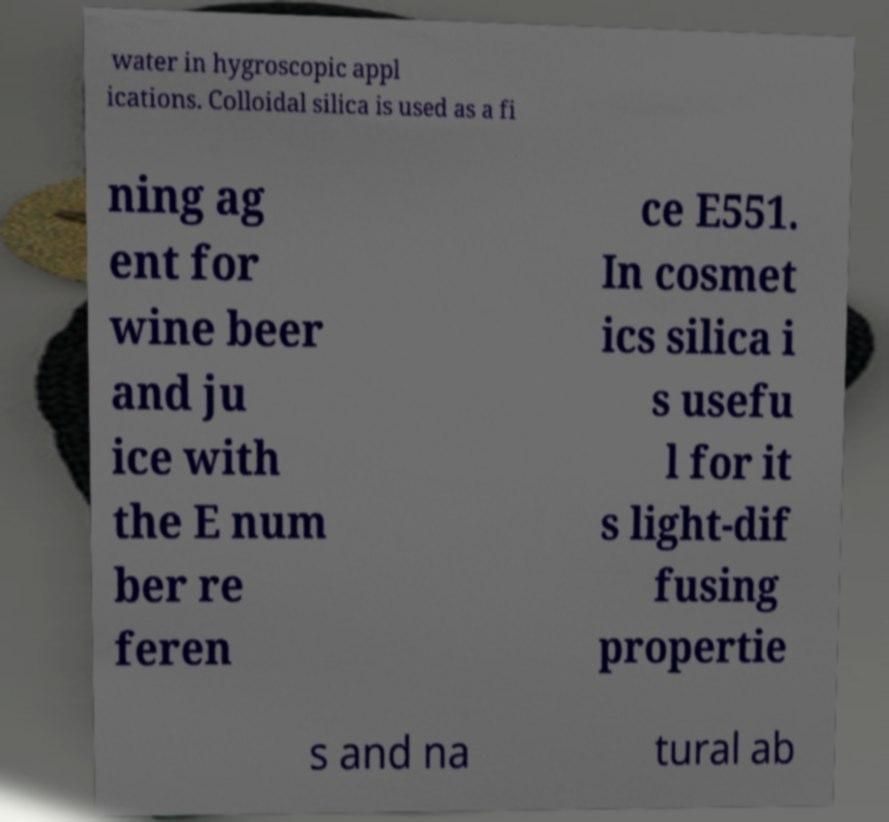What messages or text are displayed in this image? I need them in a readable, typed format. water in hygroscopic appl ications. Colloidal silica is used as a fi ning ag ent for wine beer and ju ice with the E num ber re feren ce E551. In cosmet ics silica i s usefu l for it s light-dif fusing propertie s and na tural ab 